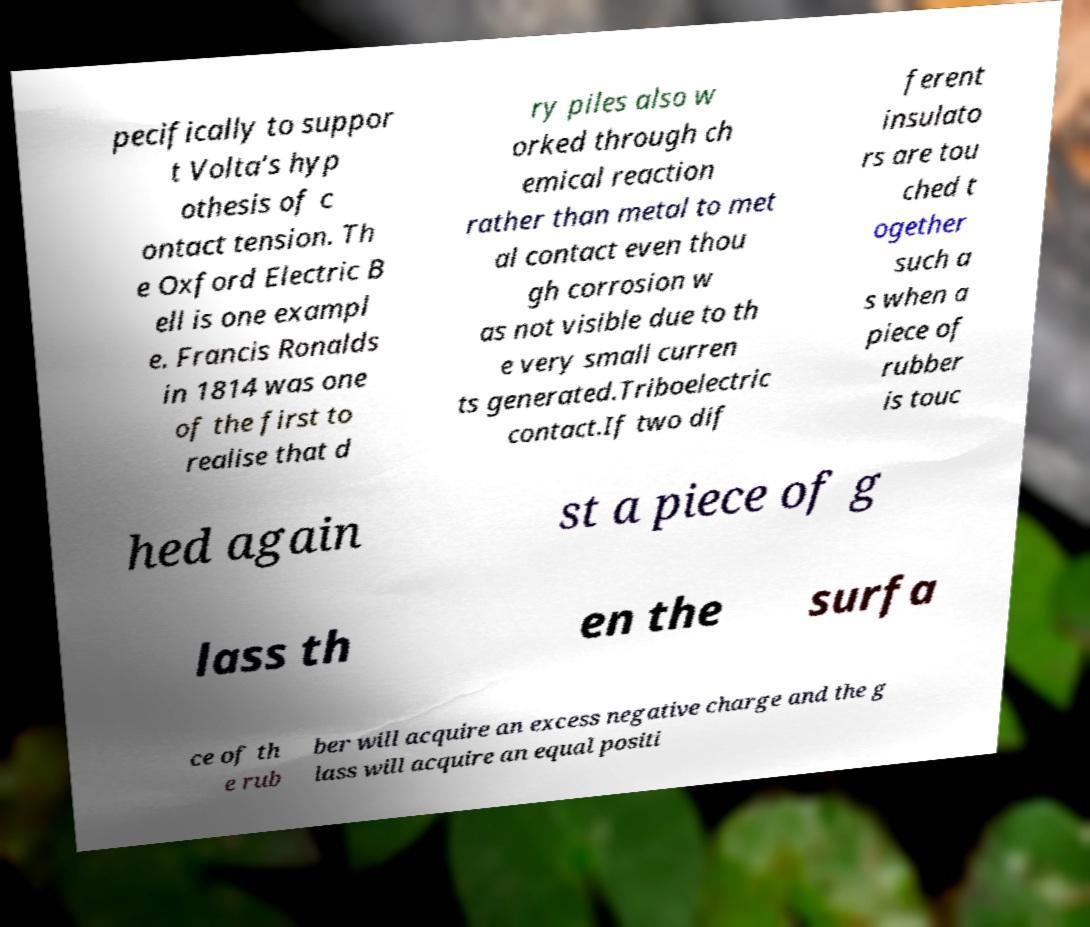Can you read and provide the text displayed in the image?This photo seems to have some interesting text. Can you extract and type it out for me? pecifically to suppor t Volta’s hyp othesis of c ontact tension. Th e Oxford Electric B ell is one exampl e. Francis Ronalds in 1814 was one of the first to realise that d ry piles also w orked through ch emical reaction rather than metal to met al contact even thou gh corrosion w as not visible due to th e very small curren ts generated.Triboelectric contact.If two dif ferent insulato rs are tou ched t ogether such a s when a piece of rubber is touc hed again st a piece of g lass th en the surfa ce of th e rub ber will acquire an excess negative charge and the g lass will acquire an equal positi 